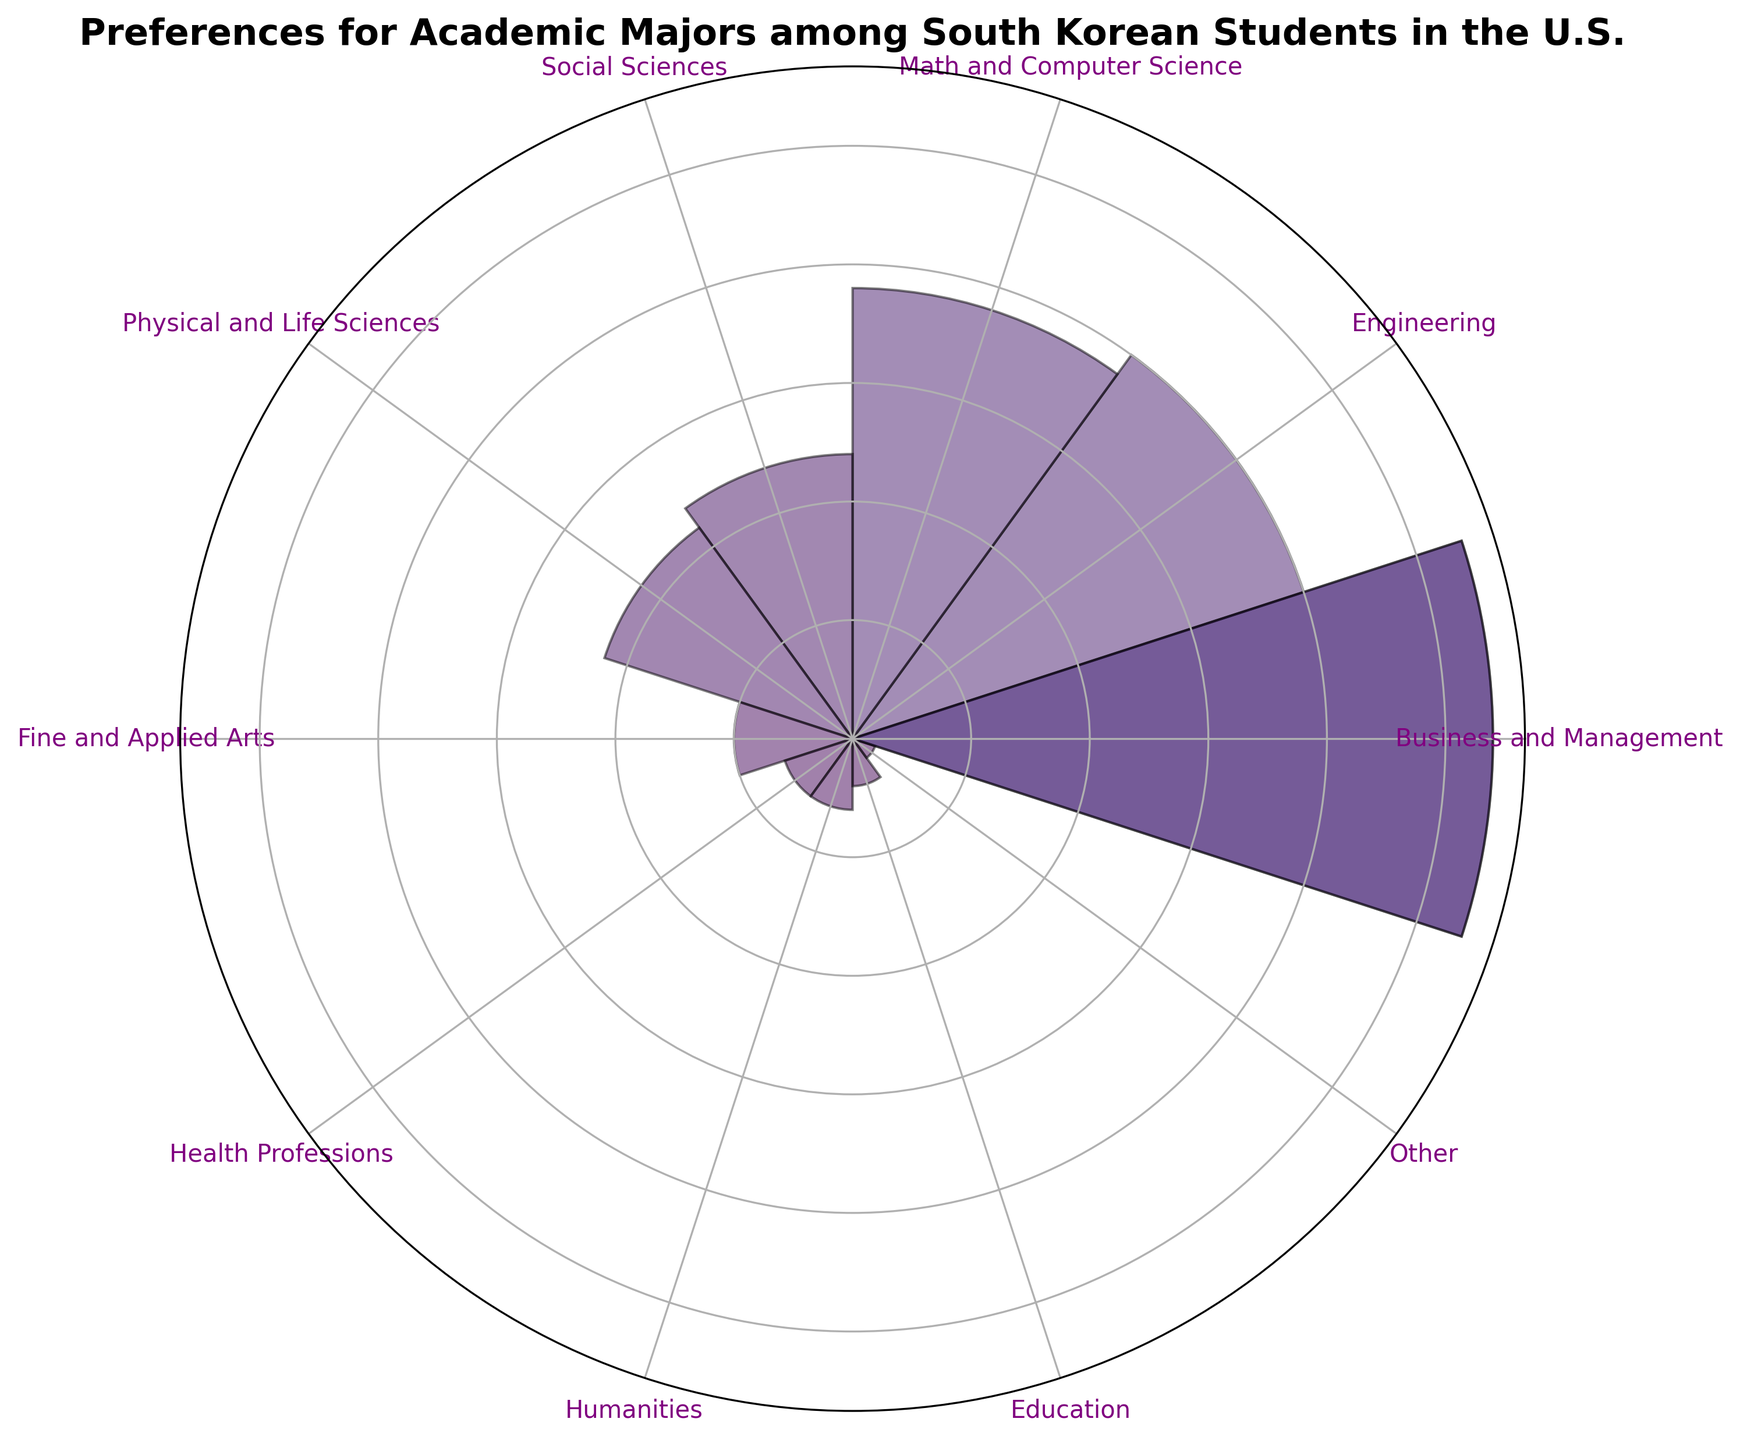What's the most popular academic major among South Korean students in the U.S.? By looking at the bar that extends the furthest from the center, we can identify the major with the highest percentage.
Answer: Business and Management What's the least popular academic major among South Korean students in the U.S.? By looking at the shortest bar, we can identify the major with the lowest percentage.
Answer: Other What's the percentage difference between the most popular and the second most popular majors? The most popular major is Business and Management with 27%, and the second most popular is Engineering with 20%. The difference is 27% - 20% = 7%.
Answer: 7% Which majors have the same percentage of students? By examining the heights of the bars, we can see that Health Professions and Humanities each have a bar of the same height representing 3%.
Answer: Health Professions and Humanities What is the combined percentage of students in majors related to sciences (Math and Computer Science, Physical and Life Sciences)? Sum the percentages for Math and Computer Science (19%) and Physical and Life Sciences (11%): 19% + 11% = 30%.
Answer: 30% Are more students enrolled in Engineering or Social Sciences? Compare the heights of the bars for Engineering (20%) and Social Sciences (12%).
Answer: Engineering Which major associated with creative fields has the higher percentage, Fine and Applied Arts or Humanities? Compare the bar heights for Fine and Applied Arts (5%) and Humanities (3%).
Answer: Fine and Applied Arts What's the mean percentage of students in the top three majors? Identify the percentages for the top three majors: Business and Management (27%), Engineering (20%), and Math and Computer Science (19%). The mean is (27% + 20% + 19%) / 3 = 22%.
Answer: 22% What percentage of students are in majors where the percentage is higher than 10%? Identify and sum percentages for all majors with values greater than 10%: Business and Management (27%), Engineering (20%), Math and Computer Science (19%), Social Sciences (12%), Physical and Life Sciences (11%). Sum is 27% + 20% + 19% + 12% + 11% = 89%.
Answer: 89% What is the range of the percentages for the listed majors? Find the difference between the highest and lowest percentages: 27% (Business and Management) - 1% (Other) = 26%.
Answer: 26% 